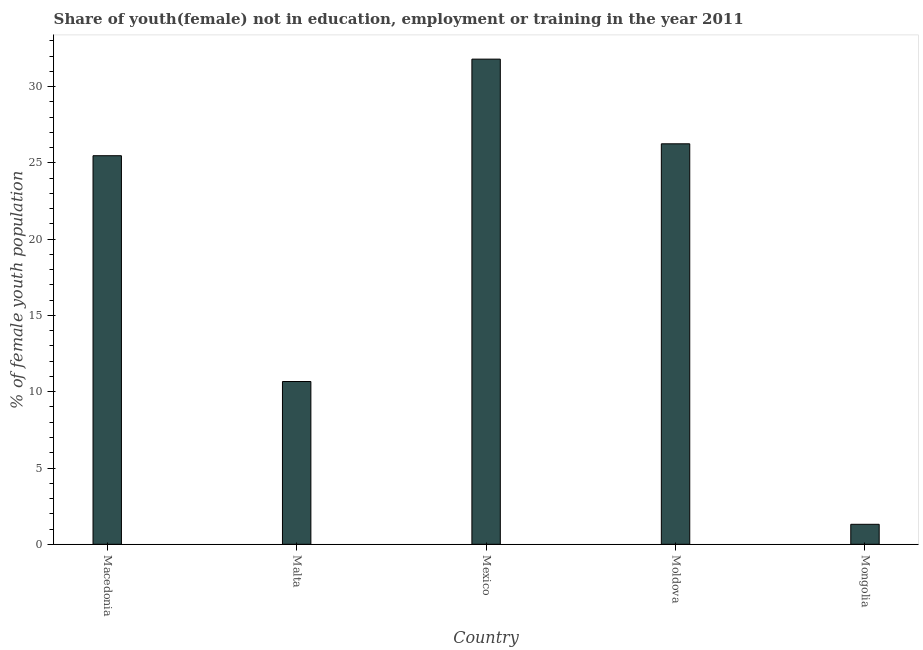What is the title of the graph?
Provide a short and direct response. Share of youth(female) not in education, employment or training in the year 2011. What is the label or title of the Y-axis?
Give a very brief answer. % of female youth population. What is the unemployed female youth population in Macedonia?
Make the answer very short. 25.47. Across all countries, what is the maximum unemployed female youth population?
Your answer should be very brief. 31.8. Across all countries, what is the minimum unemployed female youth population?
Your answer should be very brief. 1.31. In which country was the unemployed female youth population maximum?
Make the answer very short. Mexico. In which country was the unemployed female youth population minimum?
Your answer should be very brief. Mongolia. What is the sum of the unemployed female youth population?
Make the answer very short. 95.5. What is the difference between the unemployed female youth population in Mexico and Mongolia?
Your answer should be compact. 30.49. What is the average unemployed female youth population per country?
Keep it short and to the point. 19.1. What is the median unemployed female youth population?
Keep it short and to the point. 25.47. In how many countries, is the unemployed female youth population greater than 20 %?
Offer a terse response. 3. What is the ratio of the unemployed female youth population in Moldova to that in Mongolia?
Provide a succinct answer. 20.04. Is the unemployed female youth population in Macedonia less than that in Moldova?
Keep it short and to the point. Yes. What is the difference between the highest and the second highest unemployed female youth population?
Provide a succinct answer. 5.55. Is the sum of the unemployed female youth population in Moldova and Mongolia greater than the maximum unemployed female youth population across all countries?
Give a very brief answer. No. What is the difference between the highest and the lowest unemployed female youth population?
Ensure brevity in your answer.  30.49. In how many countries, is the unemployed female youth population greater than the average unemployed female youth population taken over all countries?
Keep it short and to the point. 3. Are all the bars in the graph horizontal?
Provide a succinct answer. No. How many countries are there in the graph?
Your answer should be compact. 5. What is the difference between two consecutive major ticks on the Y-axis?
Keep it short and to the point. 5. What is the % of female youth population of Macedonia?
Offer a terse response. 25.47. What is the % of female youth population of Malta?
Offer a very short reply. 10.67. What is the % of female youth population in Mexico?
Offer a terse response. 31.8. What is the % of female youth population in Moldova?
Give a very brief answer. 26.25. What is the % of female youth population of Mongolia?
Your response must be concise. 1.31. What is the difference between the % of female youth population in Macedonia and Mexico?
Keep it short and to the point. -6.33. What is the difference between the % of female youth population in Macedonia and Moldova?
Provide a succinct answer. -0.78. What is the difference between the % of female youth population in Macedonia and Mongolia?
Your answer should be compact. 24.16. What is the difference between the % of female youth population in Malta and Mexico?
Provide a succinct answer. -21.13. What is the difference between the % of female youth population in Malta and Moldova?
Provide a short and direct response. -15.58. What is the difference between the % of female youth population in Malta and Mongolia?
Your answer should be very brief. 9.36. What is the difference between the % of female youth population in Mexico and Moldova?
Provide a succinct answer. 5.55. What is the difference between the % of female youth population in Mexico and Mongolia?
Provide a succinct answer. 30.49. What is the difference between the % of female youth population in Moldova and Mongolia?
Provide a short and direct response. 24.94. What is the ratio of the % of female youth population in Macedonia to that in Malta?
Your response must be concise. 2.39. What is the ratio of the % of female youth population in Macedonia to that in Mexico?
Offer a terse response. 0.8. What is the ratio of the % of female youth population in Macedonia to that in Moldova?
Keep it short and to the point. 0.97. What is the ratio of the % of female youth population in Macedonia to that in Mongolia?
Offer a terse response. 19.44. What is the ratio of the % of female youth population in Malta to that in Mexico?
Your response must be concise. 0.34. What is the ratio of the % of female youth population in Malta to that in Moldova?
Your answer should be compact. 0.41. What is the ratio of the % of female youth population in Malta to that in Mongolia?
Keep it short and to the point. 8.14. What is the ratio of the % of female youth population in Mexico to that in Moldova?
Provide a short and direct response. 1.21. What is the ratio of the % of female youth population in Mexico to that in Mongolia?
Your answer should be very brief. 24.27. What is the ratio of the % of female youth population in Moldova to that in Mongolia?
Offer a terse response. 20.04. 